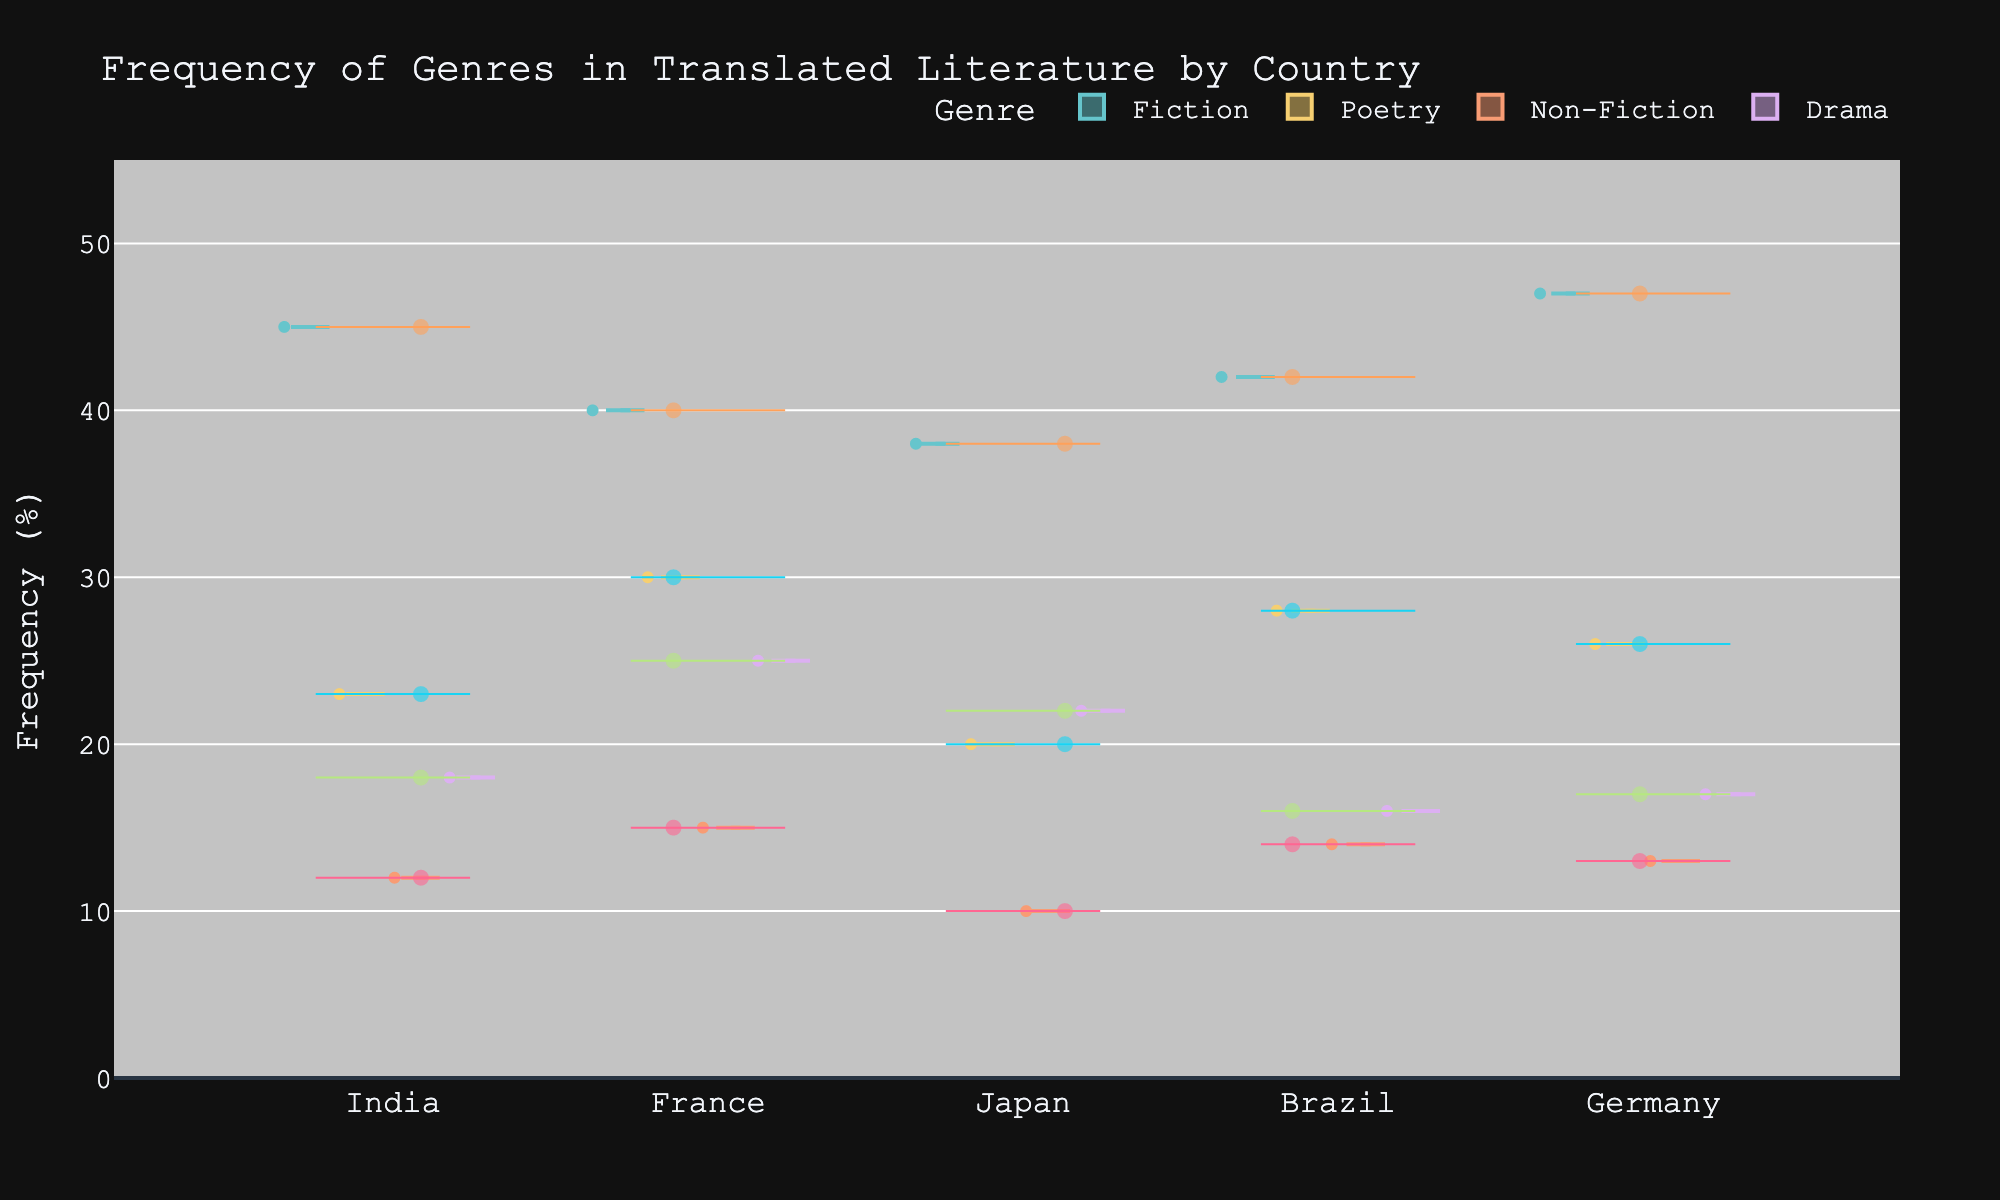What is the title of the chart? The title is often located at the top center of the chart and clearly indicates the subject. Here, it reads: "Frequency of Genres in Translated Literature by Country".
Answer: Frequency of Genres in Translated Literature by Country Which country has the highest frequency for Fiction? Look for the "Fiction" data points in all country violins and identify the highest one. The highest point is in Germany.
Answer: Germany How many genres are represented in the chart? Count the unique colors or legends that represent different genres. The chart shows Fiction, Poetry, Non-Fiction, and Drama.
Answer: 4 What is the frequency range shown on the y-axis? The y-axis labels typically provide the range. Here, it ranges from 0 to 55.
Answer: 0 to 55 Which genre has the highest median frequency across all countries? Identify the median lines in the violins for each genre. Fiction shows the highest median overall.
Answer: Fiction What is the sum of Fiction frequencies from all countries? Sum the frequencies of Fiction for each country: 45 (India) + 40 (France) + 38 (Japan) + 42 (Brazil) + 47 (Germany). The total is 212.
Answer: 212 For which genre does Japan have the lowest frequency? Inspect the Japan violin and find the lowest data points per genre. Non-Fiction has the lowest at 10.
Answer: Non-Fiction What is the difference between the highest frequency of Poetry in France and Japan? The highest frequency for Poetry in France is 30, and in Japan, it's 20. The difference is 30 - 20 = 10.
Answer: 10 Which country showcases the widest spread in Drama frequencies? Look at the width and spread of the Drama violins in each country. France shows the widest spread.
Answer: France Is the average frequency of Non-Fiction greater in India or Brazil? Calculate the average Non-Fiction frequency for India (12) and Brazil (14). Compare: 14 (Brazil) is greater than 12 (India).
Answer: Brazil 